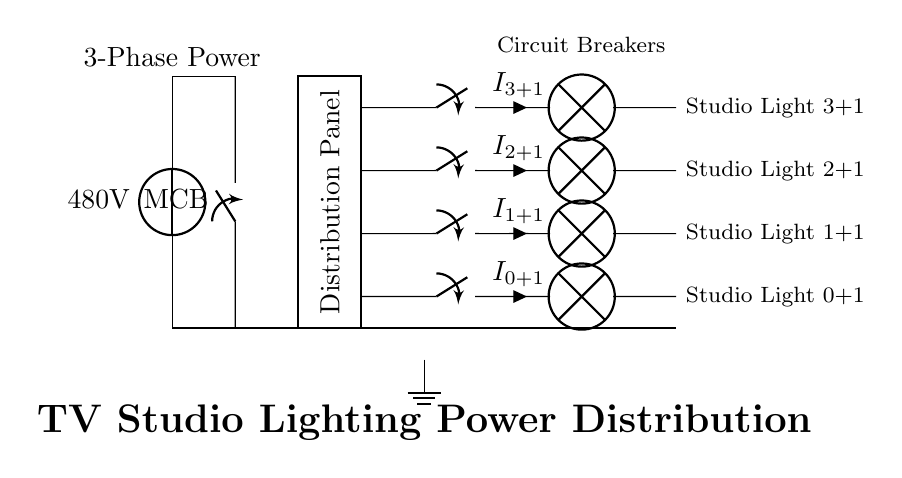What is the voltage supplied by the power source? The voltage provided by the power source in the circuit is 480 volts, as indicated next to the voltage source symbol at the top of the diagram.
Answer: 480 volts What component is located directly after the main power supply? The component located directly after the main power supply is the main circuit breaker, which is represented by the switch symbol connected vertically to the power source.
Answer: Circuit breaker How many studio lights are connected in this circuit? There are four studio lights connected in this circuit, as shown by the four outputs branching off from the distribution panel.
Answer: Four What does the ground connection indicate in this circuit? The ground connection provides a reference point for the electrical system and ensures safety by allowing excess current to safely discharge to the earth, which is depicted at the bottom of the diagram.
Answer: Safety Which component controls the individual lighting circuits? The individual lighting circuits are controlled by the circuit breakers, located just before the studio lights, which can be toggled to open or close each light circuit.
Answer: Circuit breakers What type of power is indicated at the main power supply? The main power supply supplies three-phase power, as noted by the label above the voltage source, which is crucial for distributing high power efficiently.
Answer: Three-phase 